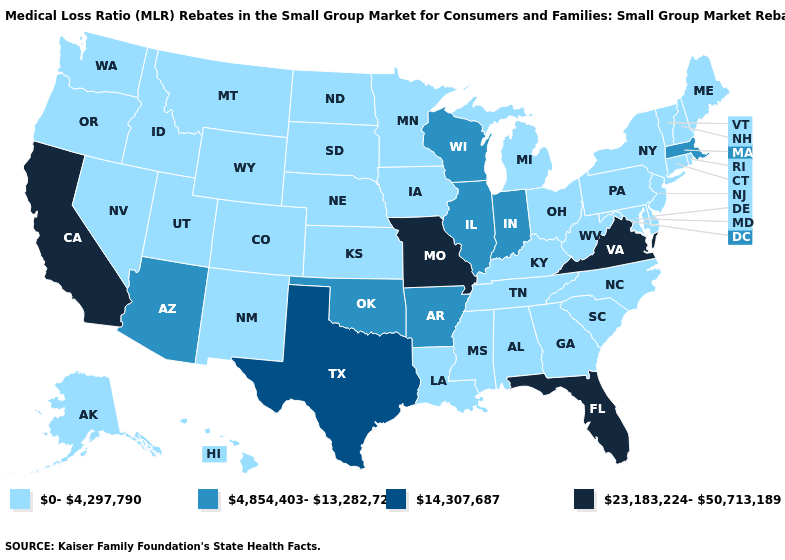Does Massachusetts have the lowest value in the Northeast?
Concise answer only. No. What is the lowest value in the MidWest?
Quick response, please. 0-4,297,790. What is the value of Maryland?
Quick response, please. 0-4,297,790. Among the states that border Mississippi , does Tennessee have the lowest value?
Short answer required. Yes. Name the states that have a value in the range 0-4,297,790?
Be succinct. Alabama, Alaska, Colorado, Connecticut, Delaware, Georgia, Hawaii, Idaho, Iowa, Kansas, Kentucky, Louisiana, Maine, Maryland, Michigan, Minnesota, Mississippi, Montana, Nebraska, Nevada, New Hampshire, New Jersey, New Mexico, New York, North Carolina, North Dakota, Ohio, Oregon, Pennsylvania, Rhode Island, South Carolina, South Dakota, Tennessee, Utah, Vermont, Washington, West Virginia, Wyoming. Among the states that border Iowa , does Illinois have the lowest value?
Short answer required. No. What is the lowest value in the West?
Concise answer only. 0-4,297,790. What is the lowest value in the Northeast?
Quick response, please. 0-4,297,790. Which states have the lowest value in the USA?
Answer briefly. Alabama, Alaska, Colorado, Connecticut, Delaware, Georgia, Hawaii, Idaho, Iowa, Kansas, Kentucky, Louisiana, Maine, Maryland, Michigan, Minnesota, Mississippi, Montana, Nebraska, Nevada, New Hampshire, New Jersey, New Mexico, New York, North Carolina, North Dakota, Ohio, Oregon, Pennsylvania, Rhode Island, South Carolina, South Dakota, Tennessee, Utah, Vermont, Washington, West Virginia, Wyoming. Name the states that have a value in the range 0-4,297,790?
Quick response, please. Alabama, Alaska, Colorado, Connecticut, Delaware, Georgia, Hawaii, Idaho, Iowa, Kansas, Kentucky, Louisiana, Maine, Maryland, Michigan, Minnesota, Mississippi, Montana, Nebraska, Nevada, New Hampshire, New Jersey, New Mexico, New York, North Carolina, North Dakota, Ohio, Oregon, Pennsylvania, Rhode Island, South Carolina, South Dakota, Tennessee, Utah, Vermont, Washington, West Virginia, Wyoming. What is the highest value in the MidWest ?
Answer briefly. 23,183,224-50,713,189. What is the highest value in states that border Connecticut?
Quick response, please. 4,854,403-13,282,727. How many symbols are there in the legend?
Concise answer only. 4. Does the map have missing data?
Quick response, please. No. Which states have the lowest value in the USA?
Be succinct. Alabama, Alaska, Colorado, Connecticut, Delaware, Georgia, Hawaii, Idaho, Iowa, Kansas, Kentucky, Louisiana, Maine, Maryland, Michigan, Minnesota, Mississippi, Montana, Nebraska, Nevada, New Hampshire, New Jersey, New Mexico, New York, North Carolina, North Dakota, Ohio, Oregon, Pennsylvania, Rhode Island, South Carolina, South Dakota, Tennessee, Utah, Vermont, Washington, West Virginia, Wyoming. 